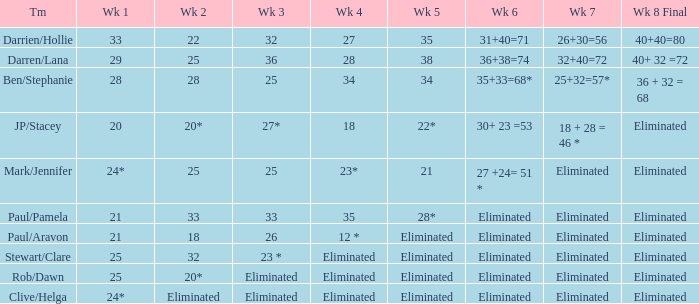Name the week 3 with week 6 of 31+40=71 32.0. 